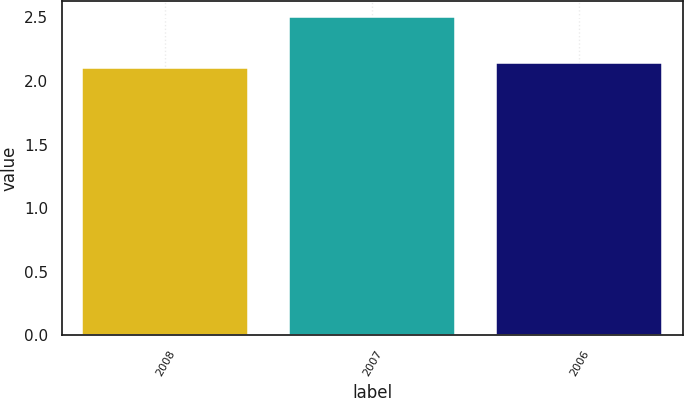<chart> <loc_0><loc_0><loc_500><loc_500><bar_chart><fcel>2008<fcel>2007<fcel>2006<nl><fcel>2.1<fcel>2.5<fcel>2.14<nl></chart> 